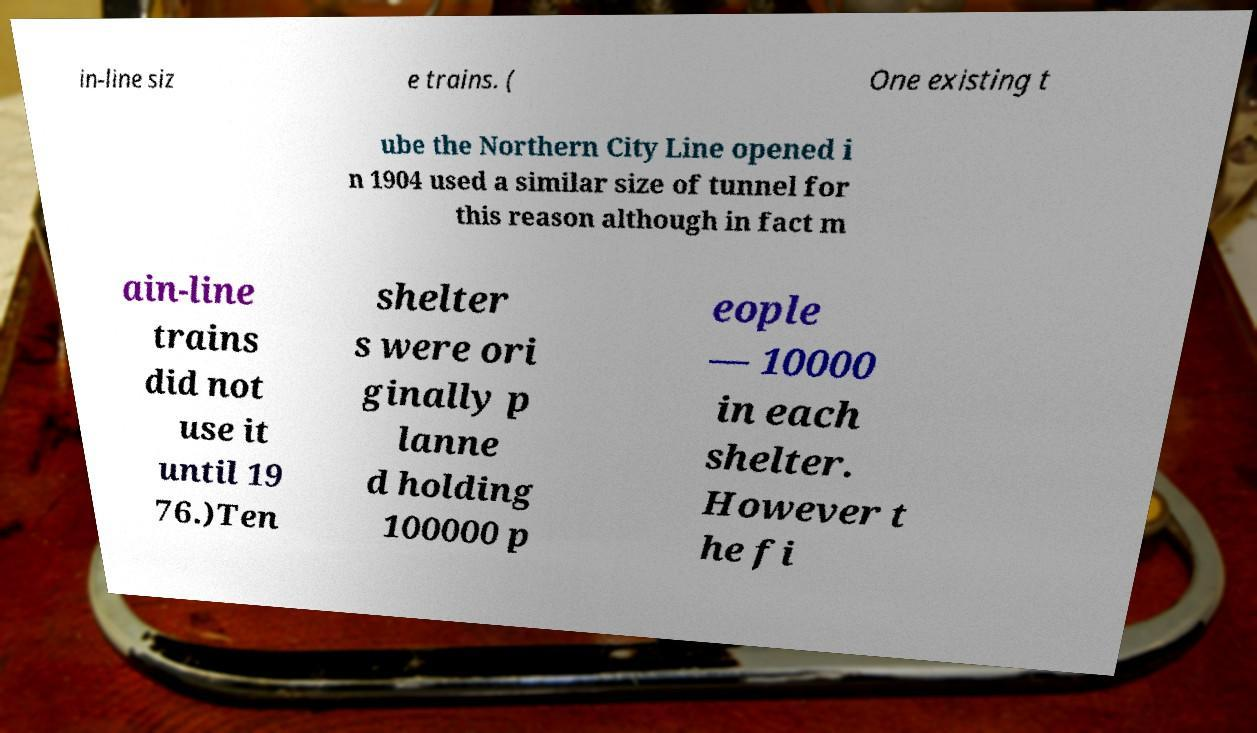For documentation purposes, I need the text within this image transcribed. Could you provide that? in-line siz e trains. ( One existing t ube the Northern City Line opened i n 1904 used a similar size of tunnel for this reason although in fact m ain-line trains did not use it until 19 76.)Ten shelter s were ori ginally p lanne d holding 100000 p eople — 10000 in each shelter. However t he fi 